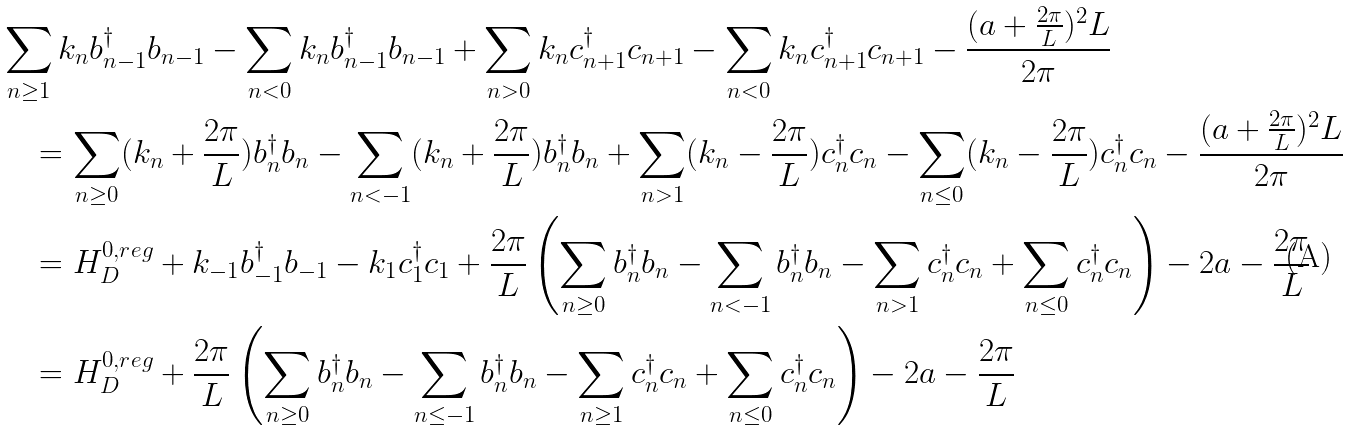Convert formula to latex. <formula><loc_0><loc_0><loc_500><loc_500>& \sum _ { n \geq 1 } k _ { n } { b } ^ { \dagger } _ { n - 1 } b _ { n - 1 } - \sum _ { n < 0 } k _ { n } { b } ^ { \dagger } _ { n - 1 } b _ { n - 1 } + \sum _ { n > 0 } k _ { n } c _ { n + 1 } ^ { \dagger } c _ { n + 1 } - \sum _ { n < 0 } k _ { n } c _ { n + 1 } ^ { \dagger } c _ { n + 1 } - \frac { ( a + \frac { 2 \pi } { L } ) ^ { 2 } L } { 2 \pi } \\ & \quad = \sum _ { n \geq 0 } ( k _ { n } + \frac { 2 \pi } { L } ) { b } ^ { \dagger } _ { n } b _ { n } - \sum _ { n < - 1 } ( k _ { n } + \frac { 2 \pi } { L } ) { b } ^ { \dagger } _ { n } b _ { n } + \sum _ { n > 1 } ( k _ { n } - \frac { 2 \pi } { L } ) c _ { n } ^ { \dagger } c _ { n } - \sum _ { n \leq 0 } ( k _ { n } - \frac { 2 \pi } { L } ) c _ { n } ^ { \dagger } c _ { n } - \frac { ( a + \frac { 2 \pi } { L } ) ^ { 2 } L } { 2 \pi } \\ & \quad = H _ { D } ^ { 0 , r e g } + k _ { - 1 } b _ { - 1 } ^ { \dagger } b _ { - 1 } - k _ { 1 } c _ { 1 } ^ { \dagger } c _ { 1 } + \frac { 2 \pi } { L } \left ( \sum _ { n \geq 0 } { b } ^ { \dagger } _ { n } b _ { n } - \sum _ { n < - 1 } { b } ^ { \dagger } _ { n } b _ { n } - \sum _ { n > 1 } c _ { n } ^ { \dagger } c _ { n } + \sum _ { n \leq 0 } c _ { n } ^ { \dagger } c _ { n } \right ) - 2 a - \frac { 2 \pi } { L } \\ & \quad = H _ { D } ^ { 0 , r e g } + \frac { 2 \pi } { L } \left ( \sum _ { n \geq 0 } { b } ^ { \dagger } _ { n } b _ { n } - \sum _ { n \leq - 1 } { b } ^ { \dagger } _ { n } b _ { n } - \sum _ { n \geq 1 } c _ { n } ^ { \dagger } c _ { n } + \sum _ { n \leq 0 } c _ { n } ^ { \dagger } c _ { n } \right ) - 2 a - \frac { 2 \pi } { L }</formula> 